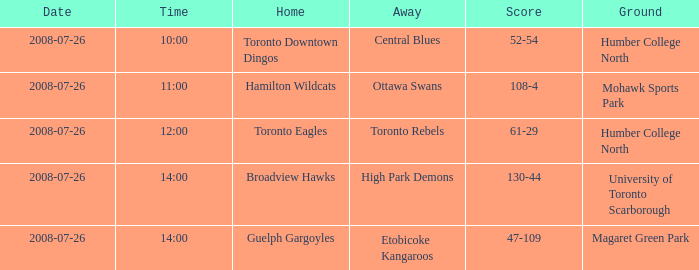When did the high park demons compete in a game outside their home ground? 2008-07-26. 